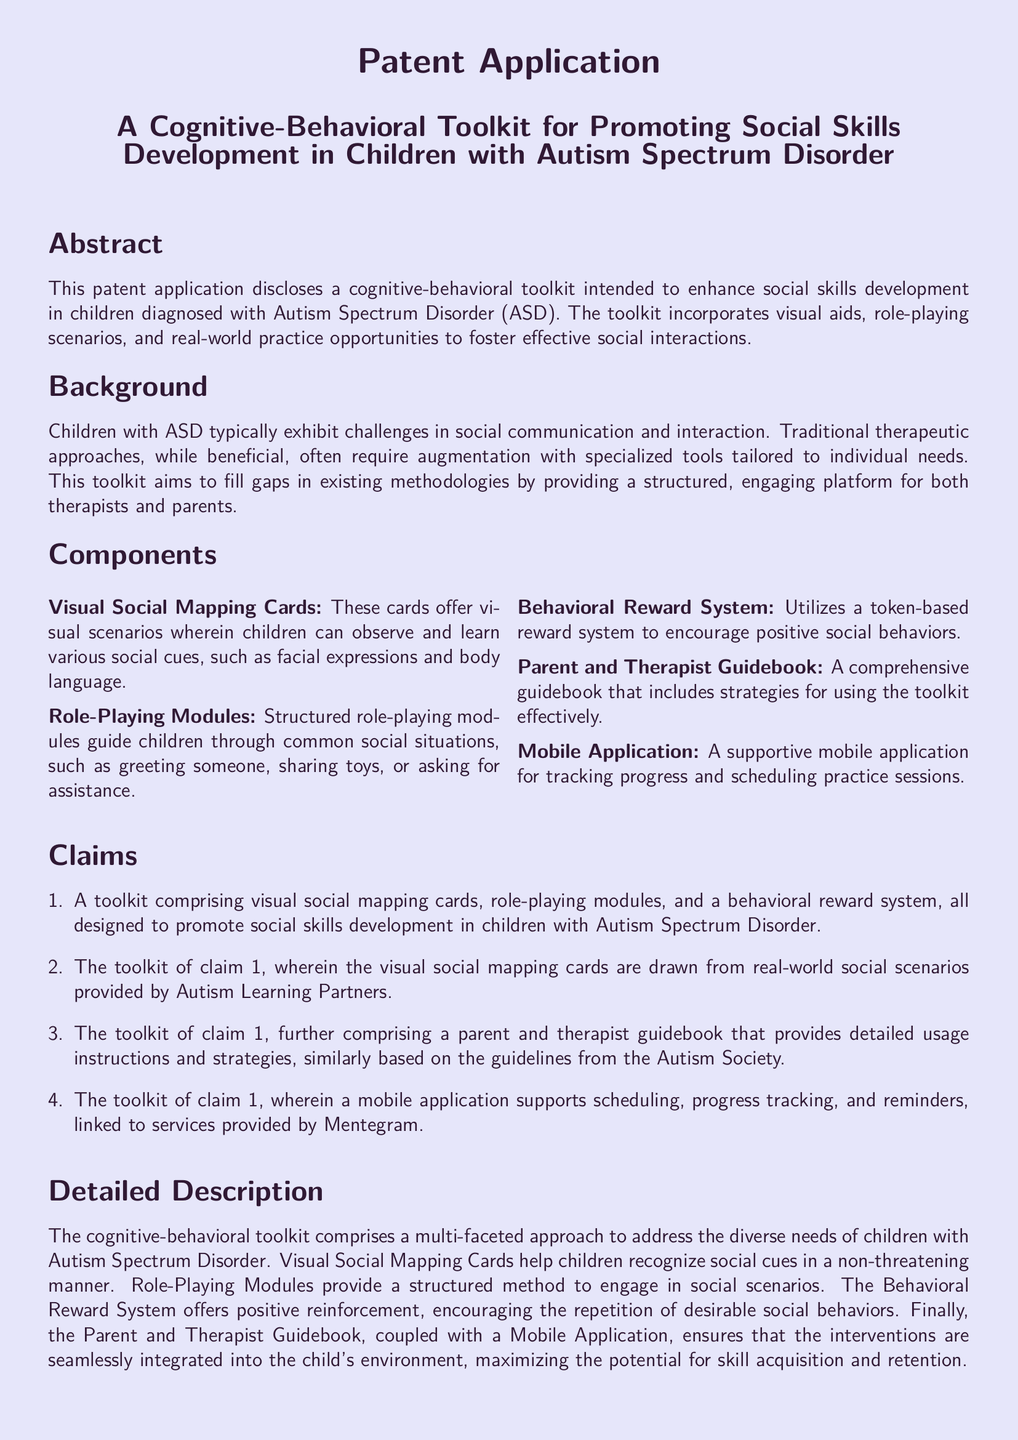What is the title of the patent application? The title is stated in the title section of the document.
Answer: A Cognitive-Behavioral Toolkit for Promoting Social Skills Development in Children with Autism Spectrum Disorder What type of children is the toolkit designed for? The document specifically mentions the target group for the toolkit.
Answer: Children with Autism Spectrum Disorder What is one component of the toolkit? The components are listed under the Components section.
Answer: Visual Social Mapping Cards What type of system does the toolkit use to encourage positive behaviors? The Behavioral Reward System is mentioned as a specific feature of the toolkit.
Answer: Token-based reward system Who provided real-world social scenarios for the toolkit? The source of social scenarios is detailed in one of the claims.
Answer: Autism Learning Partners How many claims are presented in the patent application? The number of claims is indicated in the Claims section of the document.
Answer: Four What does the mobile application support? The specific functions of the mobile application are described in the Claims section.
Answer: Scheduling, progress tracking, and reminders What is the purpose of the Parent and Therapist Guidebook? The guidebook's purpose is outlined in the Detailed Description section.
Answer: Provides detailed usage instructions and strategies What method does the Role-Playing Module guide children through? The method is described in the Components section of the document.
Answer: Common social situations 